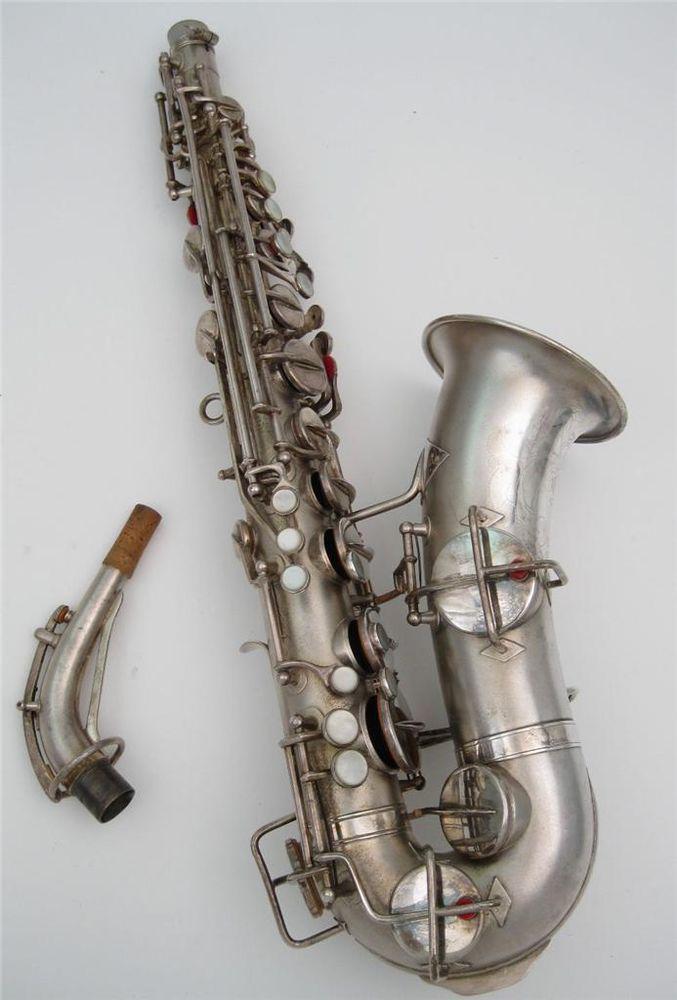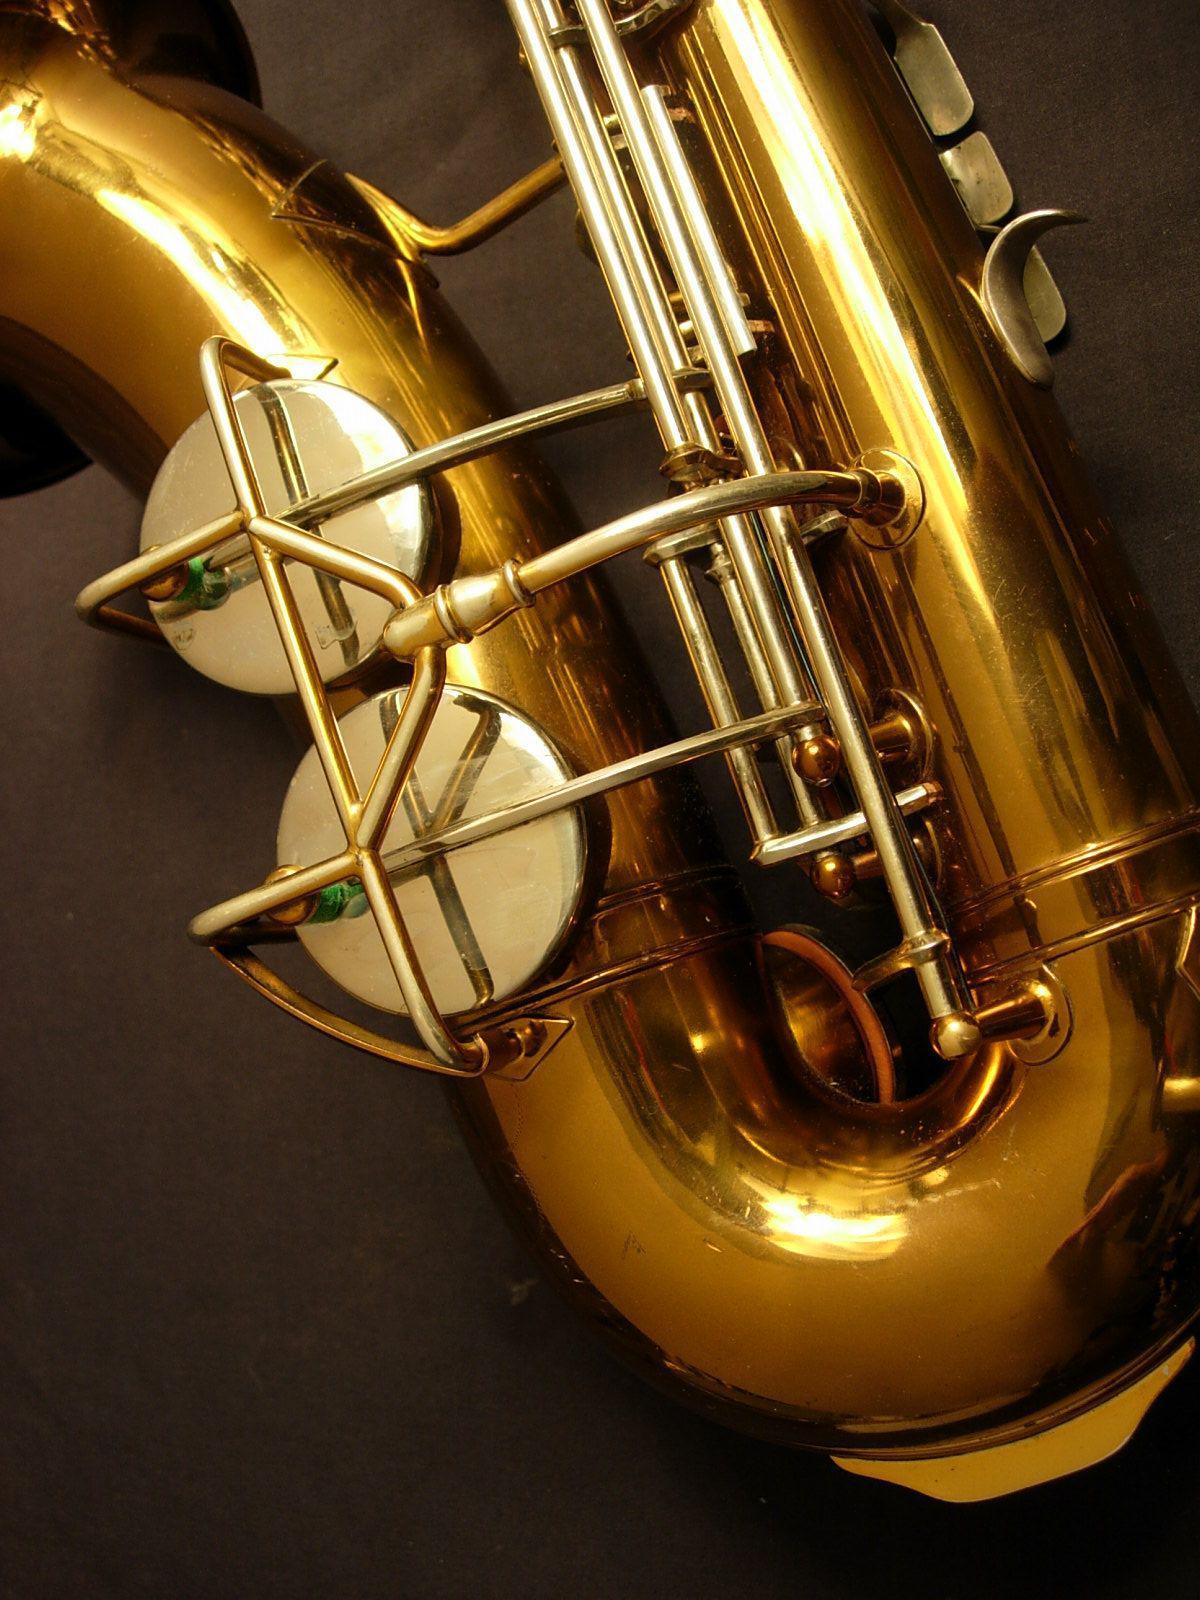The first image is the image on the left, the second image is the image on the right. Analyze the images presented: Is the assertion "One of the saxophones has etchings on it." valid? Answer yes or no. No. The first image is the image on the left, the second image is the image on the right. Evaluate the accuracy of this statement regarding the images: "The mouthpiece of the instrument is disconnected and laying next to the instrument in the left image.". Is it true? Answer yes or no. Yes. 